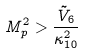Convert formula to latex. <formula><loc_0><loc_0><loc_500><loc_500>M _ { p } ^ { 2 } > \frac { \tilde { V } _ { 6 } } { \kappa _ { 1 0 } ^ { 2 } }</formula> 